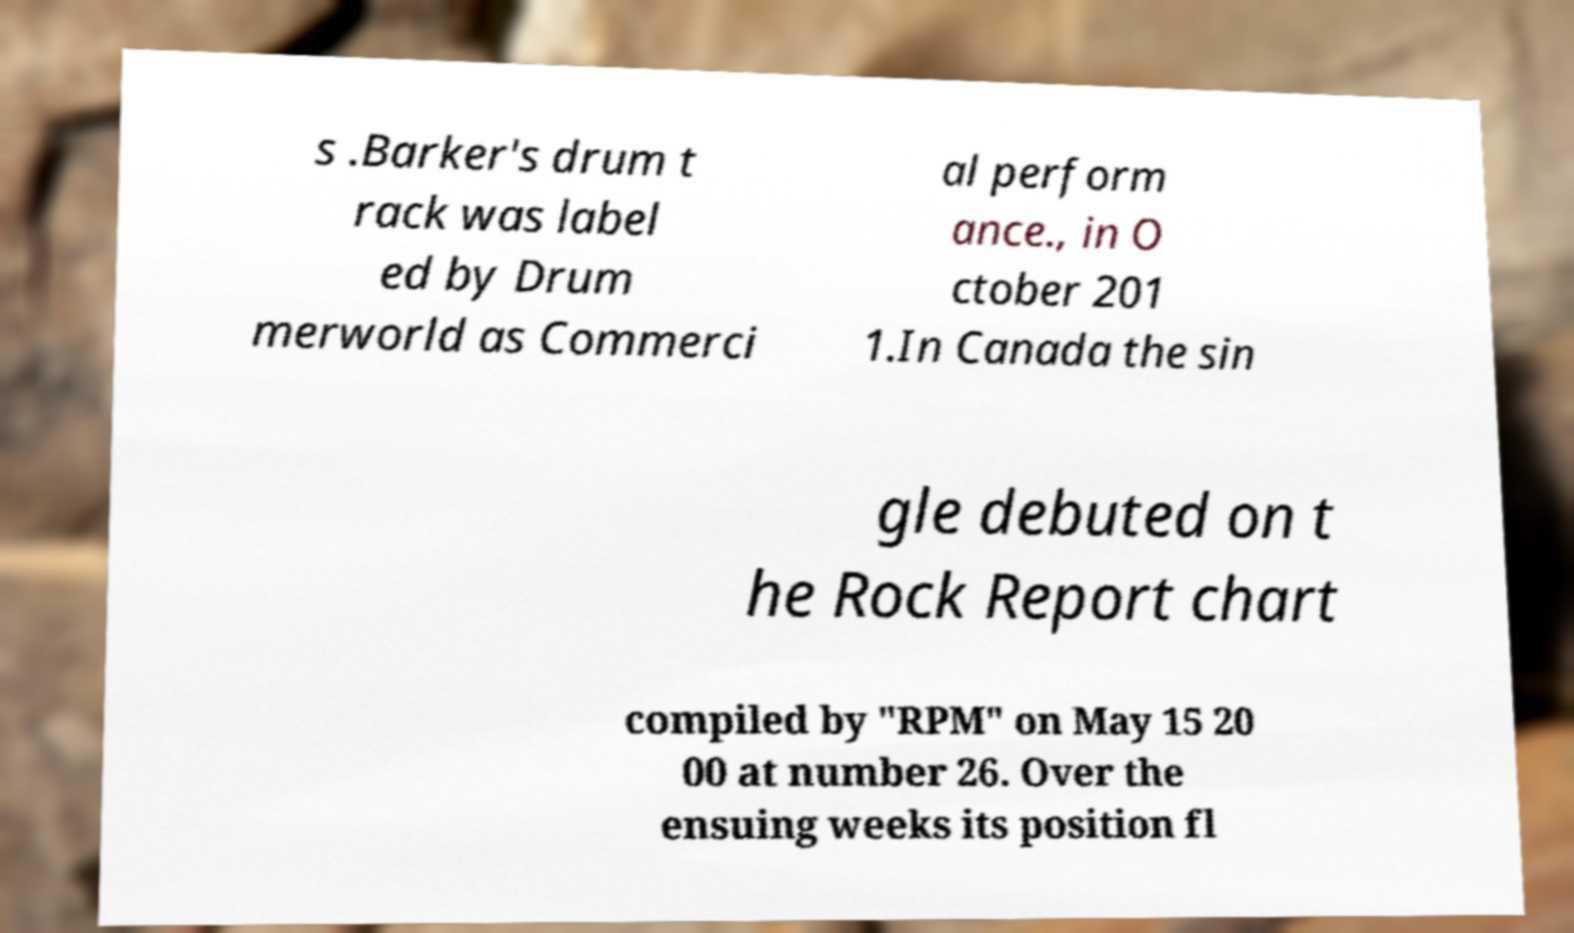Please identify and transcribe the text found in this image. s .Barker's drum t rack was label ed by Drum merworld as Commerci al perform ance., in O ctober 201 1.In Canada the sin gle debuted on t he Rock Report chart compiled by "RPM" on May 15 20 00 at number 26. Over the ensuing weeks its position fl 